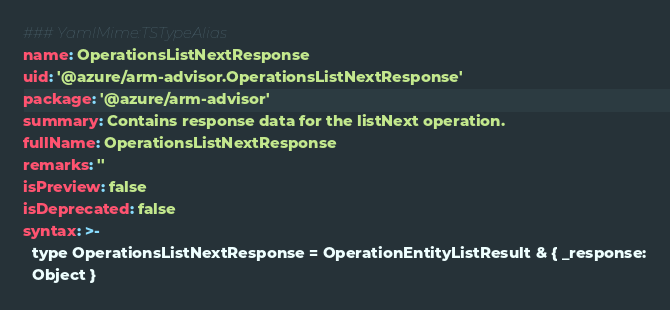Convert code to text. <code><loc_0><loc_0><loc_500><loc_500><_YAML_>### YamlMime:TSTypeAlias
name: OperationsListNextResponse
uid: '@azure/arm-advisor.OperationsListNextResponse'
package: '@azure/arm-advisor'
summary: Contains response data for the listNext operation.
fullName: OperationsListNextResponse
remarks: ''
isPreview: false
isDeprecated: false
syntax: >-
  type OperationsListNextResponse = OperationEntityListResult & { _response:
  Object }
</code> 